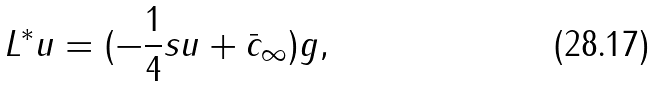Convert formula to latex. <formula><loc_0><loc_0><loc_500><loc_500>L ^ { * } u = ( - \frac { 1 } { 4 } s u + \bar { c } _ { \infty } ) g ,</formula> 